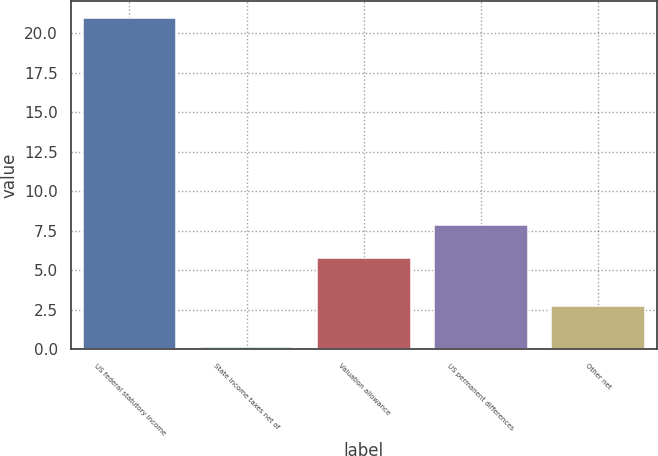Convert chart to OTSL. <chart><loc_0><loc_0><loc_500><loc_500><bar_chart><fcel>US federal statutory income<fcel>State income taxes net of<fcel>Valuation allowance<fcel>US permanent differences<fcel>Other net<nl><fcel>21<fcel>0.1<fcel>5.8<fcel>7.89<fcel>2.7<nl></chart> 